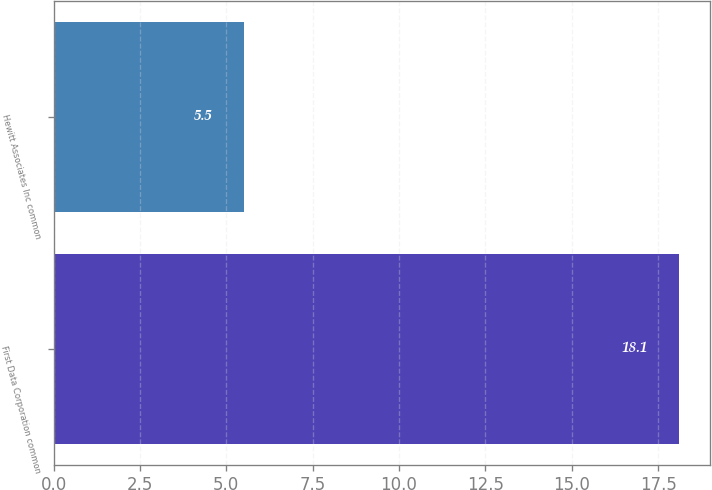Convert chart. <chart><loc_0><loc_0><loc_500><loc_500><bar_chart><fcel>First Data Corporation common<fcel>Hewitt Associates Inc common<nl><fcel>18.1<fcel>5.5<nl></chart> 